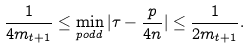Convert formula to latex. <formula><loc_0><loc_0><loc_500><loc_500>\frac { 1 } { 4 m _ { t + 1 } } \leq \min _ { p o d d } | \tau - \frac { p } { 4 n } | \leq \frac { 1 } { 2 m _ { t + 1 } } .</formula> 